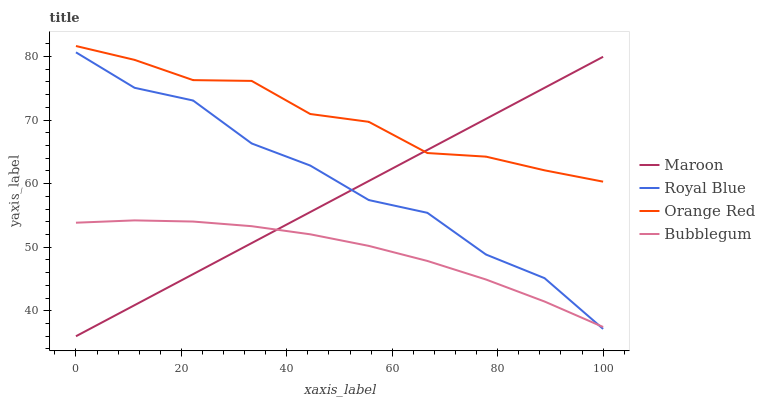Does Bubblegum have the minimum area under the curve?
Answer yes or no. Yes. Does Orange Red have the maximum area under the curve?
Answer yes or no. Yes. Does Orange Red have the minimum area under the curve?
Answer yes or no. No. Does Bubblegum have the maximum area under the curve?
Answer yes or no. No. Is Maroon the smoothest?
Answer yes or no. Yes. Is Royal Blue the roughest?
Answer yes or no. Yes. Is Bubblegum the smoothest?
Answer yes or no. No. Is Bubblegum the roughest?
Answer yes or no. No. Does Maroon have the lowest value?
Answer yes or no. Yes. Does Bubblegum have the lowest value?
Answer yes or no. No. Does Orange Red have the highest value?
Answer yes or no. Yes. Does Bubblegum have the highest value?
Answer yes or no. No. Is Bubblegum less than Orange Red?
Answer yes or no. Yes. Is Orange Red greater than Bubblegum?
Answer yes or no. Yes. Does Maroon intersect Royal Blue?
Answer yes or no. Yes. Is Maroon less than Royal Blue?
Answer yes or no. No. Is Maroon greater than Royal Blue?
Answer yes or no. No. Does Bubblegum intersect Orange Red?
Answer yes or no. No. 